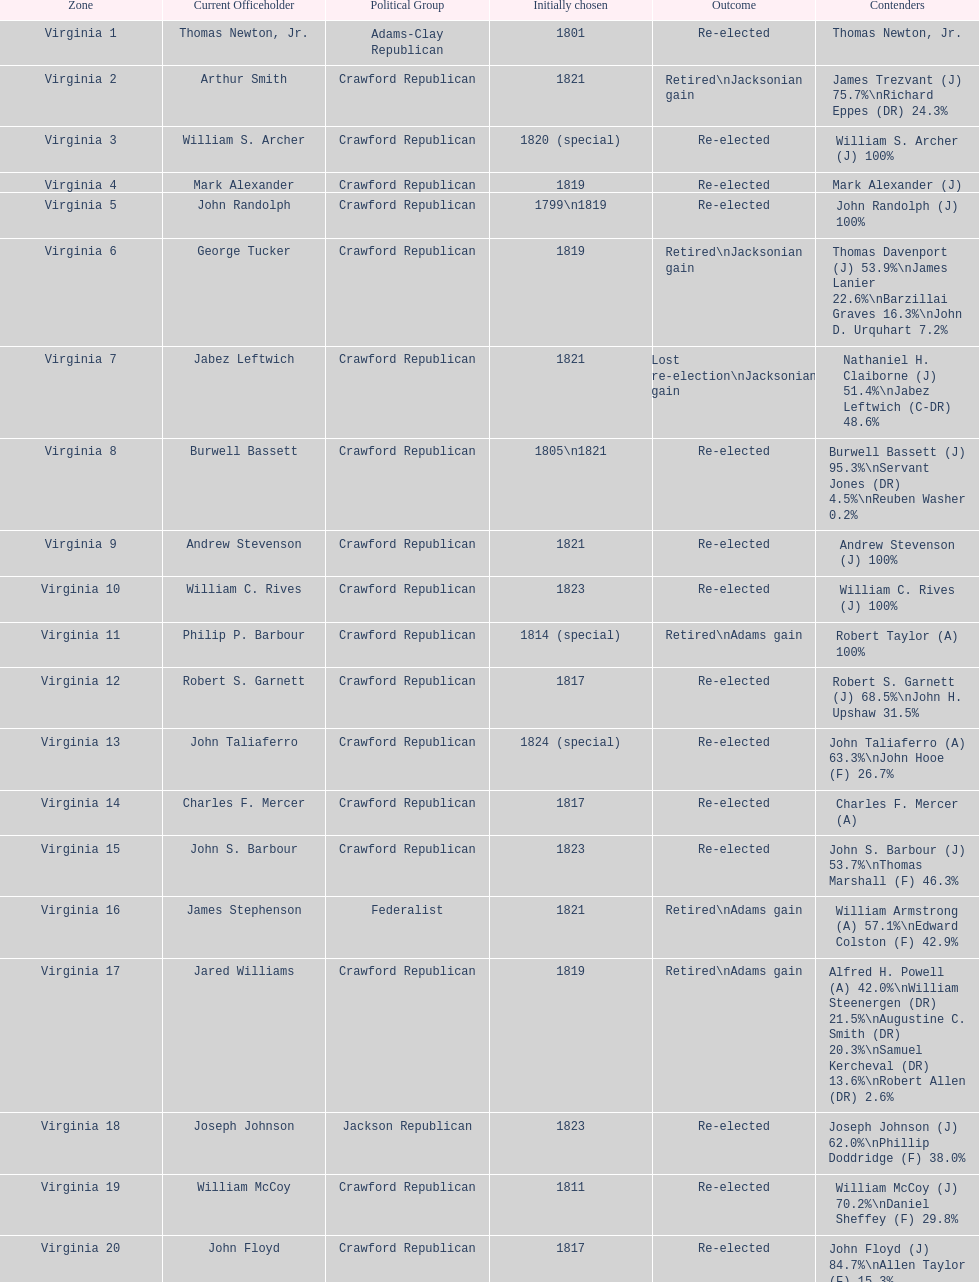How many candidates were there for virginia 17 district? 5. 